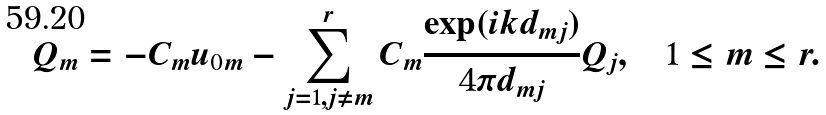Convert formula to latex. <formula><loc_0><loc_0><loc_500><loc_500>Q _ { m } = - C _ { m } u _ { 0 m } - \sum ^ { r } _ { j = 1 , j \neq m } C _ { m } \frac { \exp ( i k d _ { m j } ) } { 4 \pi d _ { m j } } Q _ { j } , \quad 1 \leq m \leq r .</formula> 